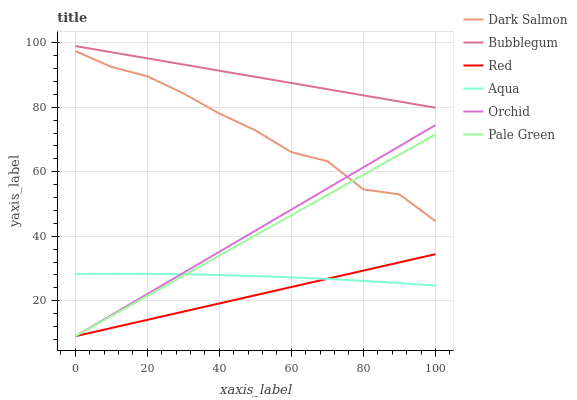Does Red have the minimum area under the curve?
Answer yes or no. Yes. Does Bubblegum have the maximum area under the curve?
Answer yes or no. Yes. Does Dark Salmon have the minimum area under the curve?
Answer yes or no. No. Does Dark Salmon have the maximum area under the curve?
Answer yes or no. No. Is Pale Green the smoothest?
Answer yes or no. Yes. Is Dark Salmon the roughest?
Answer yes or no. Yes. Is Bubblegum the smoothest?
Answer yes or no. No. Is Bubblegum the roughest?
Answer yes or no. No. Does Pale Green have the lowest value?
Answer yes or no. Yes. Does Dark Salmon have the lowest value?
Answer yes or no. No. Does Bubblegum have the highest value?
Answer yes or no. Yes. Does Dark Salmon have the highest value?
Answer yes or no. No. Is Red less than Dark Salmon?
Answer yes or no. Yes. Is Bubblegum greater than Aqua?
Answer yes or no. Yes. Does Dark Salmon intersect Orchid?
Answer yes or no. Yes. Is Dark Salmon less than Orchid?
Answer yes or no. No. Is Dark Salmon greater than Orchid?
Answer yes or no. No. Does Red intersect Dark Salmon?
Answer yes or no. No. 